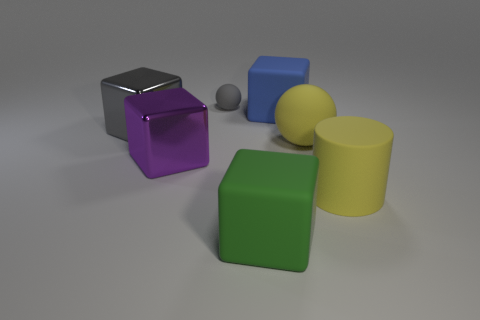What number of rubber things are large purple things or small green blocks?
Provide a succinct answer. 0. How many cyan things are either small rubber objects or matte objects?
Keep it short and to the point. 0. There is a big shiny object behind the big purple object; is its color the same as the small matte thing?
Offer a very short reply. Yes. Is the big sphere made of the same material as the small gray object?
Provide a succinct answer. Yes. Are there an equal number of tiny gray things that are behind the small sphere and cylinders that are right of the large blue rubber cube?
Make the answer very short. No. There is a gray object that is the same shape as the big blue matte object; what is it made of?
Offer a very short reply. Metal. The metal object in front of the rubber sphere in front of the rubber sphere left of the big blue cube is what shape?
Provide a short and direct response. Cube. Is the number of big blue matte blocks behind the big yellow cylinder greater than the number of brown shiny cubes?
Your answer should be very brief. Yes. Is the shape of the yellow rubber object that is behind the big yellow cylinder the same as  the gray matte object?
Your answer should be very brief. Yes. What material is the large cube that is in front of the yellow cylinder?
Your answer should be very brief. Rubber. 